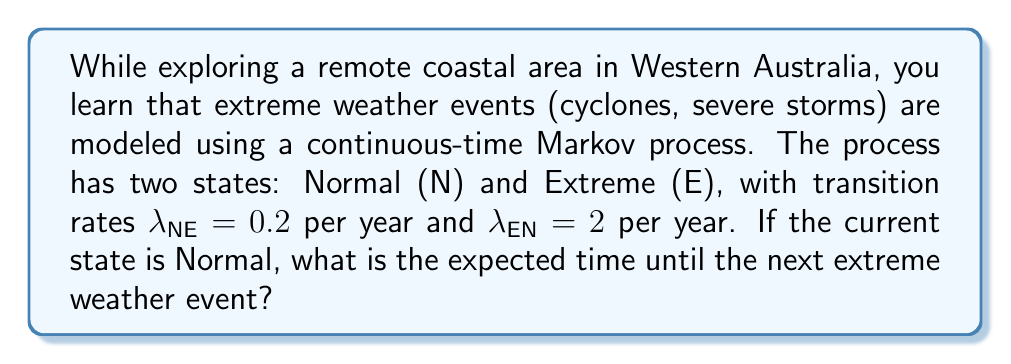Help me with this question. To solve this problem, we'll use the properties of continuous-time Markov processes:

1) In a two-state continuous-time Markov process, the time spent in each state follows an exponential distribution.

2) The parameter of the exponential distribution is the transition rate out of the current state.

3) For an exponential distribution with rate parameter $\lambda$, the expected value (mean) is $\frac{1}{\lambda}$.

Given:
- Current state: Normal (N)
- Transition rate from Normal to Extreme: $\lambda_{NE} = 0.2$ per year

Steps:
1) The time until the next transition from Normal to Extreme follows an exponential distribution with rate $\lambda_{NE} = 0.2$ per year.

2) The expected time (in years) is:

   $$E[T] = \frac{1}{\lambda_{NE}} = \frac{1}{0.2} = 5$$

Therefore, the expected time until the next extreme weather event is 5 years.
Answer: 5 years 